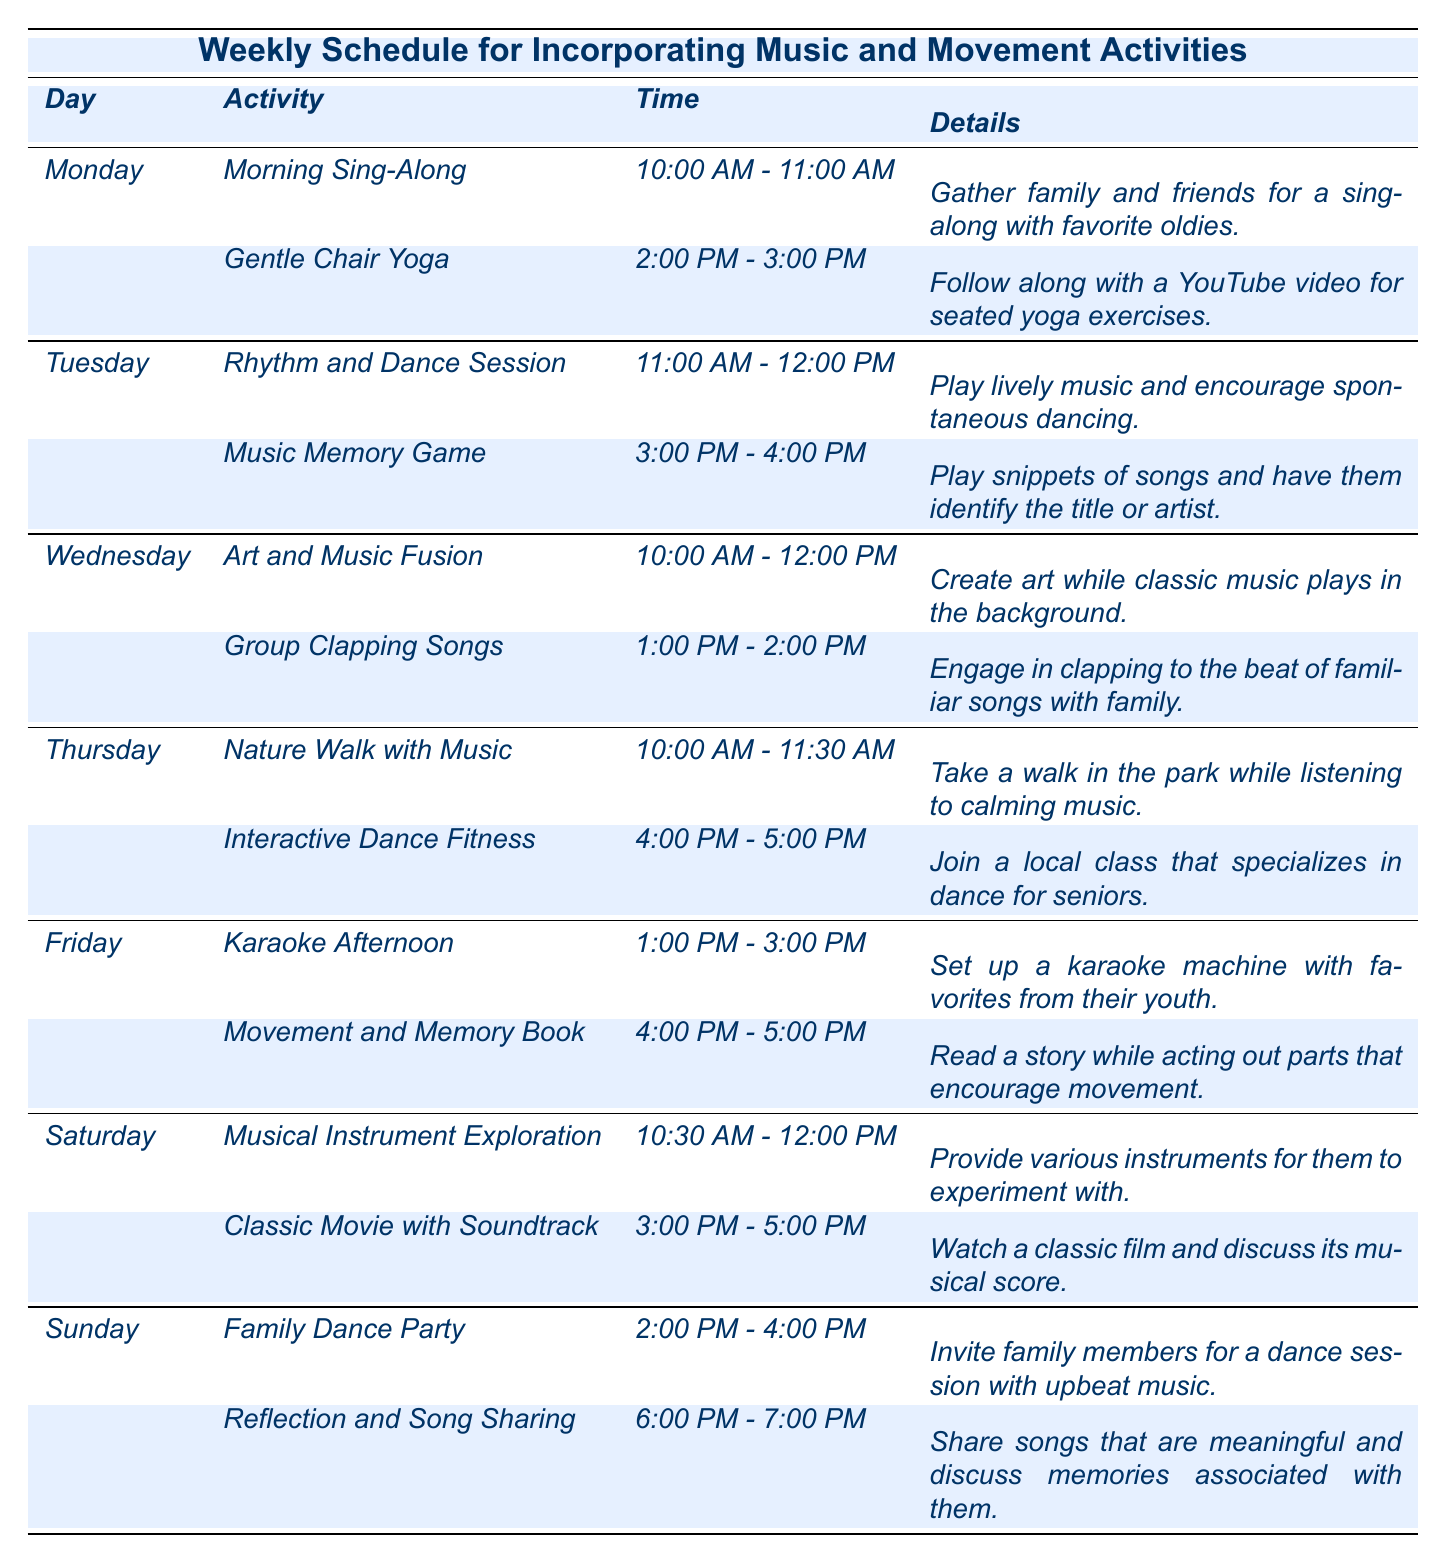What activity is scheduled for Friday at 4:00 PM? The table shows that on Friday, at 4:00 PM, there is an activity called "Movement and Memory Book."
Answer: Movement and Memory Book How many music-related activities are scheduled for Saturday? On Saturday, there are two activities listed: "Musical Instrument Exploration" and "Classic Movie with Soundtrack," making a total of two music-related activities.
Answer: 2 Is there an activity related to yoga in the schedule? Yes, the schedule includes "Gentle Chair Yoga" on Monday from 2:00 PM to 3:00 PM.
Answer: Yes What time does the "Family Dance Party" start on Sunday? According to the table, the "Family Dance Party" is scheduled to start at 2:00 PM on Sunday.
Answer: 2:00 PM How many activities are there in total throughout the week? By counting all the activities listed in the table, there are 14 activities scheduled throughout the week (2 for each of the 7 days).
Answer: 14 Which day has the most scheduled activities? Each day has 2 activities scheduled, except for Friday, which has 2, so there isn't a day with more activities; they are all equal.
Answer: No day has more; all are equal Is there a music memory game scheduled in the week? Yes, there is a "Music Memory Game" scheduled for Tuesday from 3:00 PM to 4:00 PM.
Answer: Yes What is the difference in time between the earliest and latest activity in the schedule? The earliest activity is "Morning Sing-Along" at 10:00 AM on Monday and the latest is "Reflection and Song Sharing" at 7:00 PM on Sunday. This is a difference of 9 hours.
Answer: 9 hours On which days are activities scheduled after 4:00 PM? The activities scheduled after 4:00 PM are on Thursday (Interactive Dance Fitness at 4:00 PM), Friday (Karaoke Afternoon at 1:00 PM), and Sunday (Reflection and Song Sharing at 6:00 PM).
Answer: Thursday, Friday, Sunday What type of activity is offered in the afternoon on Friday? The afternoon activities on Friday are "Karaoke Afternoon" from 1:00 PM to 3:00 PM and "Movement and Memory Book" from 4:00 PM to 5:00 PM, both of which involve music and movement.
Answer: Karaoke and Movement activities 